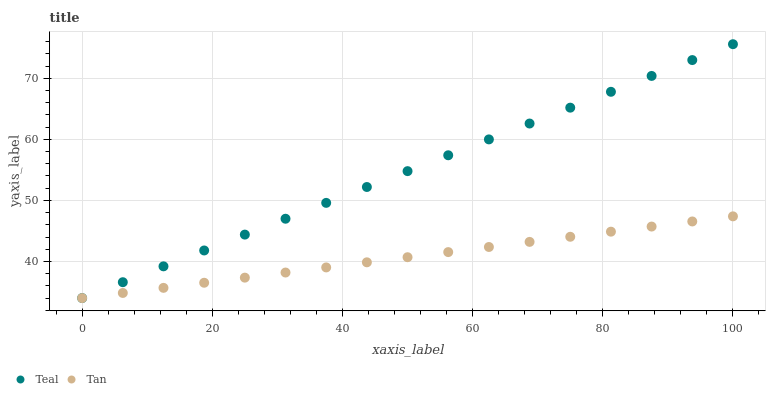Does Tan have the minimum area under the curve?
Answer yes or no. Yes. Does Teal have the maximum area under the curve?
Answer yes or no. Yes. Does Teal have the minimum area under the curve?
Answer yes or no. No. Is Tan the smoothest?
Answer yes or no. Yes. Is Teal the roughest?
Answer yes or no. Yes. Is Teal the smoothest?
Answer yes or no. No. Does Tan have the lowest value?
Answer yes or no. Yes. Does Teal have the highest value?
Answer yes or no. Yes. Does Teal intersect Tan?
Answer yes or no. Yes. Is Teal less than Tan?
Answer yes or no. No. Is Teal greater than Tan?
Answer yes or no. No. 